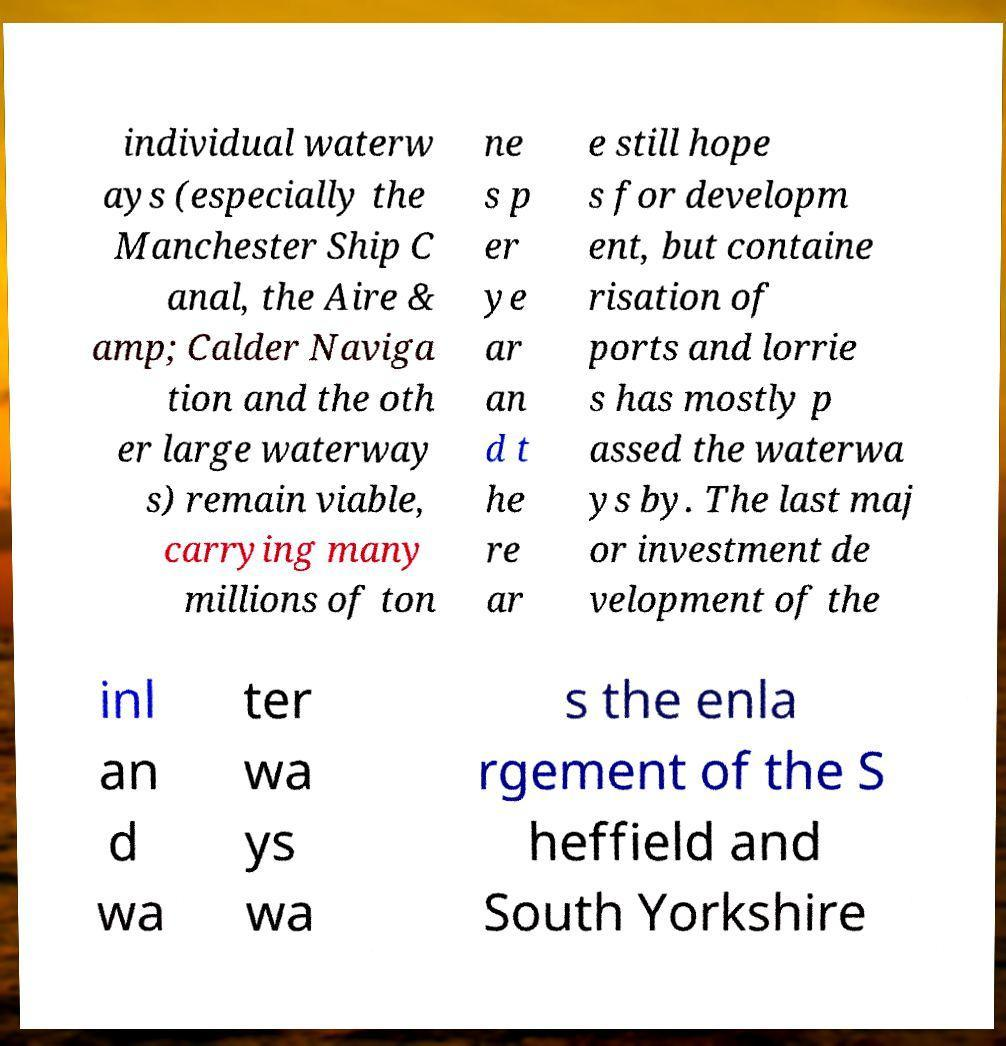Can you read and provide the text displayed in the image?This photo seems to have some interesting text. Can you extract and type it out for me? individual waterw ays (especially the Manchester Ship C anal, the Aire & amp; Calder Naviga tion and the oth er large waterway s) remain viable, carrying many millions of ton ne s p er ye ar an d t he re ar e still hope s for developm ent, but containe risation of ports and lorrie s has mostly p assed the waterwa ys by. The last maj or investment de velopment of the inl an d wa ter wa ys wa s the enla rgement of the S heffield and South Yorkshire 